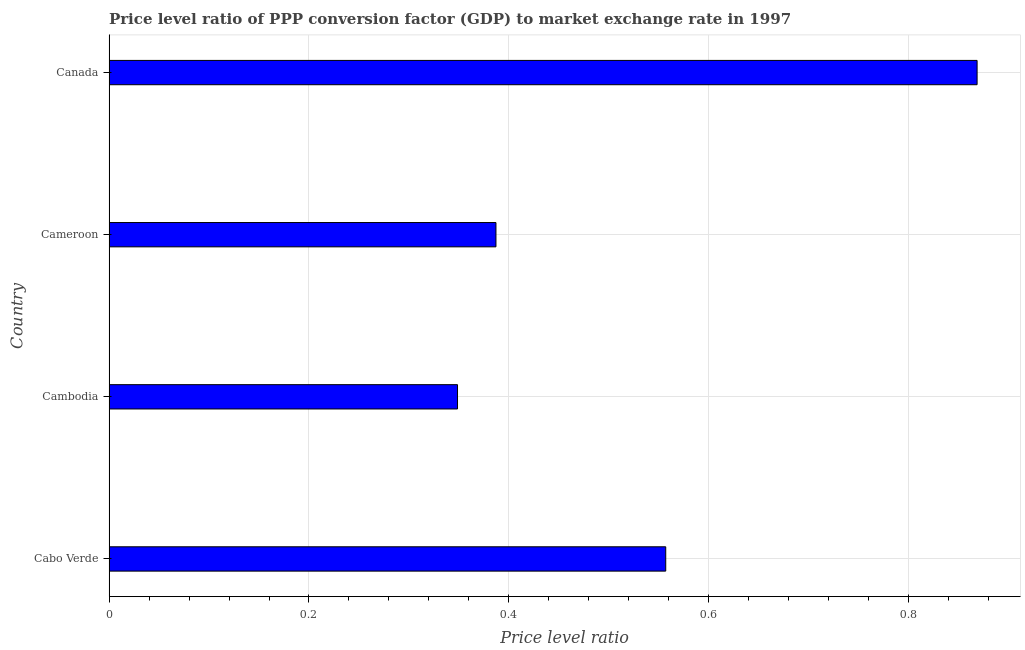Does the graph contain any zero values?
Ensure brevity in your answer.  No. Does the graph contain grids?
Give a very brief answer. Yes. What is the title of the graph?
Your response must be concise. Price level ratio of PPP conversion factor (GDP) to market exchange rate in 1997. What is the label or title of the X-axis?
Make the answer very short. Price level ratio. What is the label or title of the Y-axis?
Ensure brevity in your answer.  Country. What is the price level ratio in Canada?
Your answer should be compact. 0.87. Across all countries, what is the maximum price level ratio?
Ensure brevity in your answer.  0.87. Across all countries, what is the minimum price level ratio?
Your answer should be compact. 0.35. In which country was the price level ratio minimum?
Your response must be concise. Cambodia. What is the sum of the price level ratio?
Provide a short and direct response. 2.16. What is the difference between the price level ratio in Cambodia and Cameroon?
Give a very brief answer. -0.04. What is the average price level ratio per country?
Make the answer very short. 0.54. What is the median price level ratio?
Ensure brevity in your answer.  0.47. In how many countries, is the price level ratio greater than 0.76 ?
Offer a terse response. 1. What is the ratio of the price level ratio in Cambodia to that in Cameroon?
Ensure brevity in your answer.  0.9. Is the price level ratio in Cabo Verde less than that in Canada?
Provide a succinct answer. Yes. Is the difference between the price level ratio in Cabo Verde and Cameroon greater than the difference between any two countries?
Offer a terse response. No. What is the difference between the highest and the second highest price level ratio?
Your answer should be compact. 0.31. Is the sum of the price level ratio in Cambodia and Canada greater than the maximum price level ratio across all countries?
Ensure brevity in your answer.  Yes. What is the difference between the highest and the lowest price level ratio?
Keep it short and to the point. 0.52. Are all the bars in the graph horizontal?
Your answer should be very brief. Yes. How many countries are there in the graph?
Provide a succinct answer. 4. What is the difference between two consecutive major ticks on the X-axis?
Keep it short and to the point. 0.2. Are the values on the major ticks of X-axis written in scientific E-notation?
Provide a short and direct response. No. What is the Price level ratio in Cabo Verde?
Provide a short and direct response. 0.56. What is the Price level ratio in Cambodia?
Keep it short and to the point. 0.35. What is the Price level ratio of Cameroon?
Your answer should be compact. 0.39. What is the Price level ratio of Canada?
Provide a succinct answer. 0.87. What is the difference between the Price level ratio in Cabo Verde and Cambodia?
Make the answer very short. 0.21. What is the difference between the Price level ratio in Cabo Verde and Cameroon?
Provide a short and direct response. 0.17. What is the difference between the Price level ratio in Cabo Verde and Canada?
Offer a very short reply. -0.31. What is the difference between the Price level ratio in Cambodia and Cameroon?
Ensure brevity in your answer.  -0.04. What is the difference between the Price level ratio in Cambodia and Canada?
Your answer should be compact. -0.52. What is the difference between the Price level ratio in Cameroon and Canada?
Provide a short and direct response. -0.48. What is the ratio of the Price level ratio in Cabo Verde to that in Cambodia?
Offer a very short reply. 1.6. What is the ratio of the Price level ratio in Cabo Verde to that in Cameroon?
Your answer should be compact. 1.44. What is the ratio of the Price level ratio in Cabo Verde to that in Canada?
Offer a very short reply. 0.64. What is the ratio of the Price level ratio in Cambodia to that in Cameroon?
Your answer should be compact. 0.9. What is the ratio of the Price level ratio in Cambodia to that in Canada?
Keep it short and to the point. 0.4. What is the ratio of the Price level ratio in Cameroon to that in Canada?
Your answer should be very brief. 0.45. 